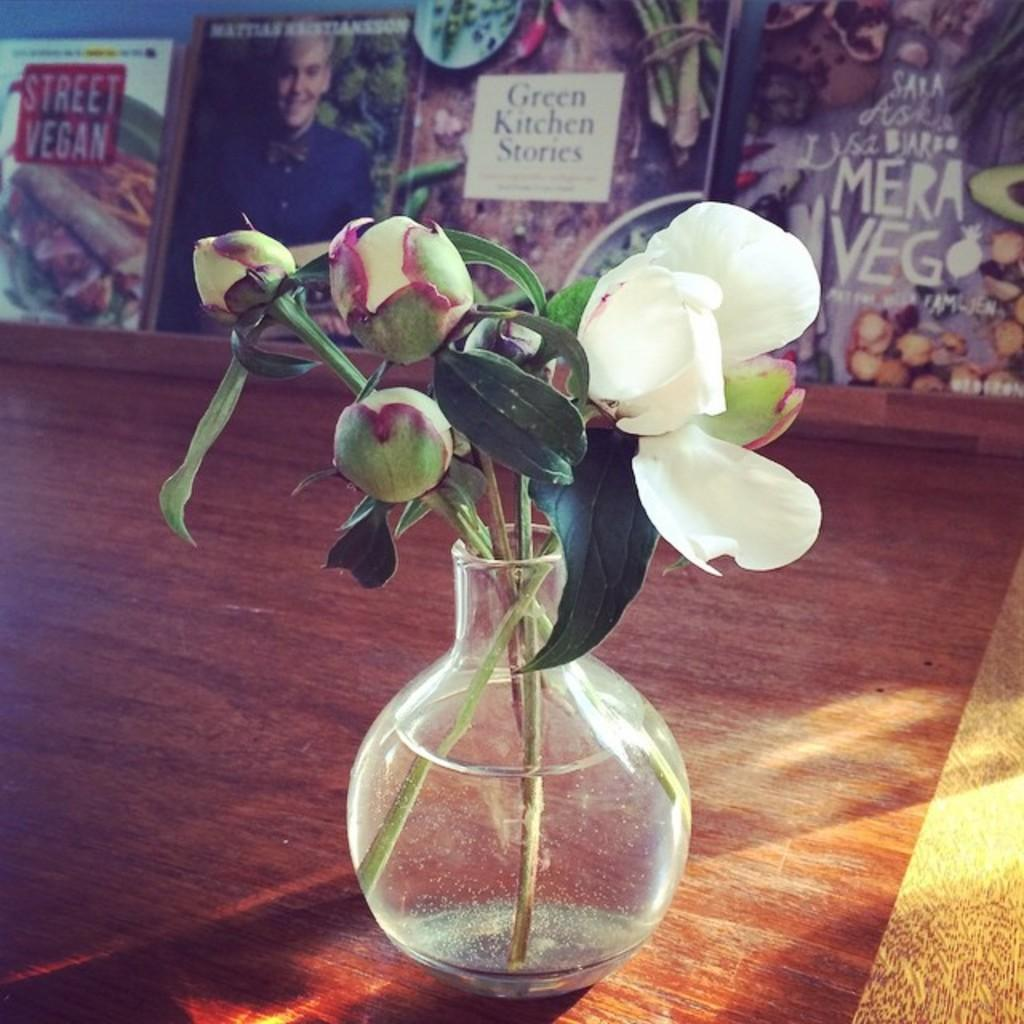What is the main object in the image? There is a flower vase in the image. What is inside the flower vase? The flower vase contains water. What is floating in the water inside the vase? There are flower beds in the water inside the vase. Where is the flower vase located? The flower vase is on a table. What can be seen behind the table? There are books behind the table. What type of reaction can be seen between the letters and the quarter in the image? There are no letters or quarters present in the image, so no such reaction can be observed. 